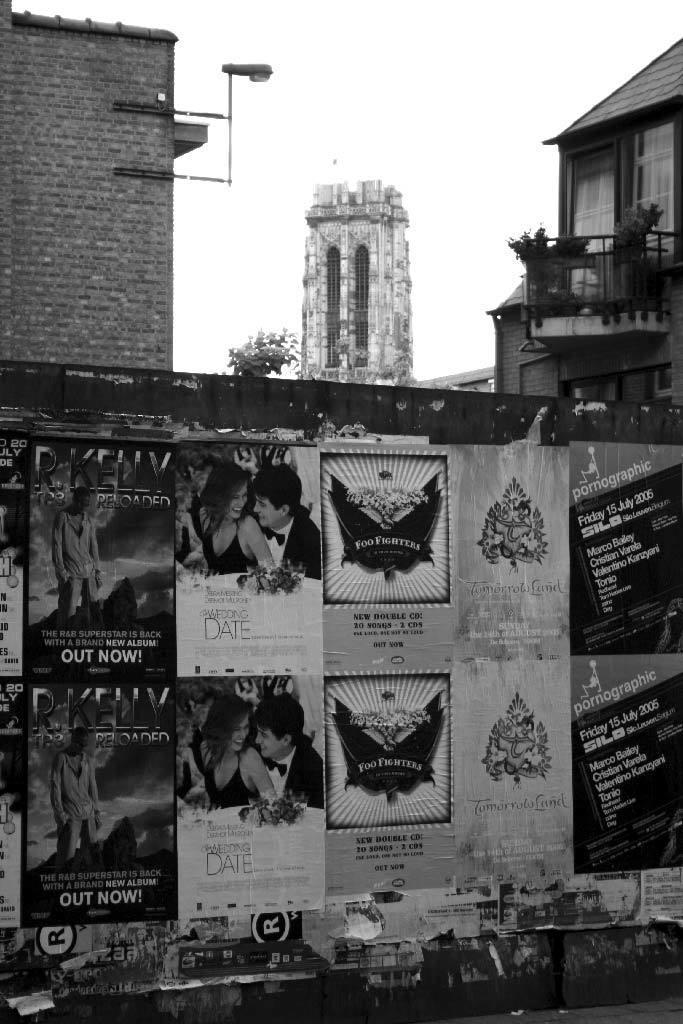Describe this image in one or two sentences. In the image we can see there are many posters stick to the wall. These are the buildings, balcony, plant, light, footpath and white sky. 